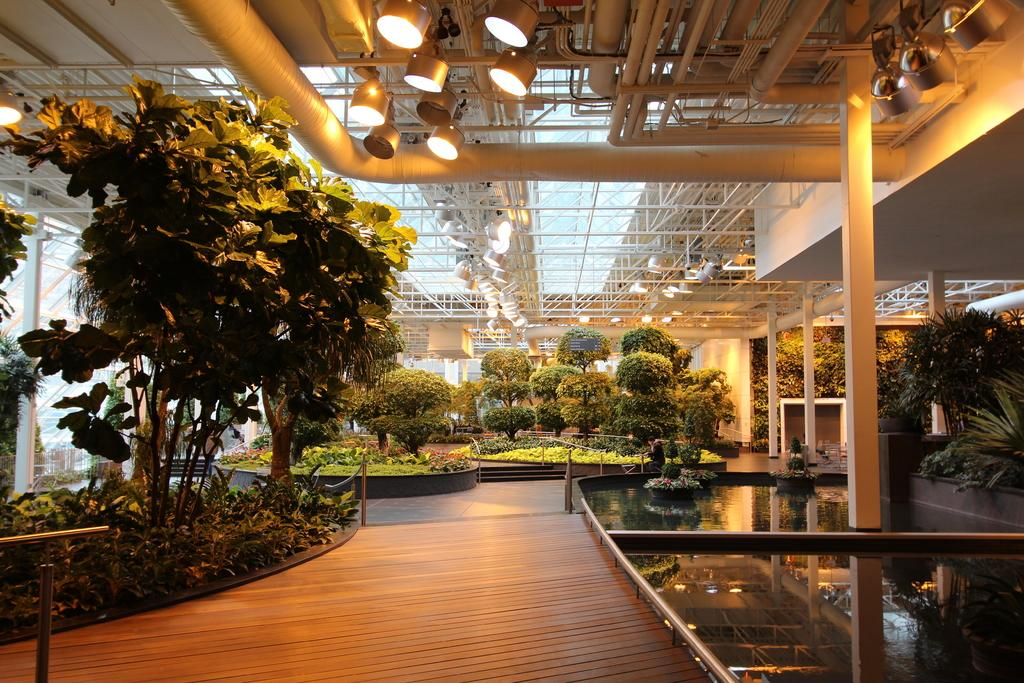What structural elements can be seen in the image? There are beams in the image. What can be found in the image that provides illumination? There are lights in the image. What type of natural elements are present in the image? There are trees and plants in the image. What type of landscape feature is visible in the image? There is water visible in the image. What safety feature can be seen in the image? There are railings in the image. What else is present in the image besides the mentioned elements? There are objects in the image. What part of the image shows the surface on which people can walk or stand? The floor is visible at the bottom portion of the picture. How quiet is the appliance in the image? There is no appliance present in the image. What type of cable can be seen connecting the objects in the image? There is no cable connecting the objects in the image. 